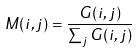Convert formula to latex. <formula><loc_0><loc_0><loc_500><loc_500>M ( i , j ) = \frac { G ( i , j ) } { \sum _ { j } G ( i , j ) }</formula> 